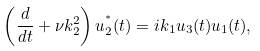<formula> <loc_0><loc_0><loc_500><loc_500>\left ( \frac { d } { d t } + \nu k _ { 2 } ^ { 2 } \right ) u _ { 2 } ^ { ^ { * } } ( t ) = i k _ { 1 } u _ { 3 } ( t ) u _ { 1 } ( t ) ,</formula> 